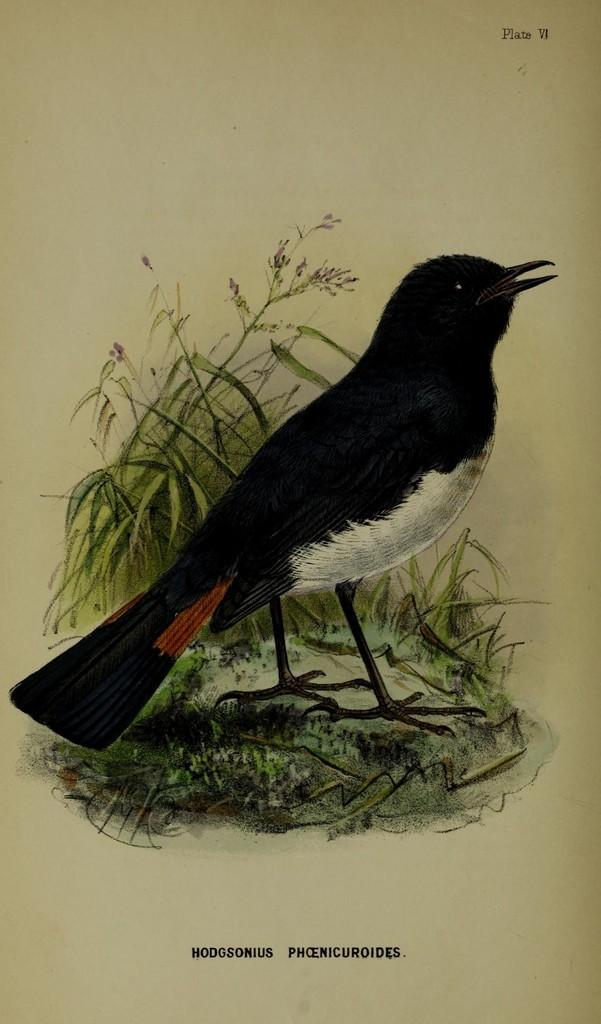What is present in the image that contains both images and text? There is a poster in the image that contains images and text. Where is the brother standing in the image? There is no brother present in the image. What type of dock can be seen in the image? There is no dock present in the image. 